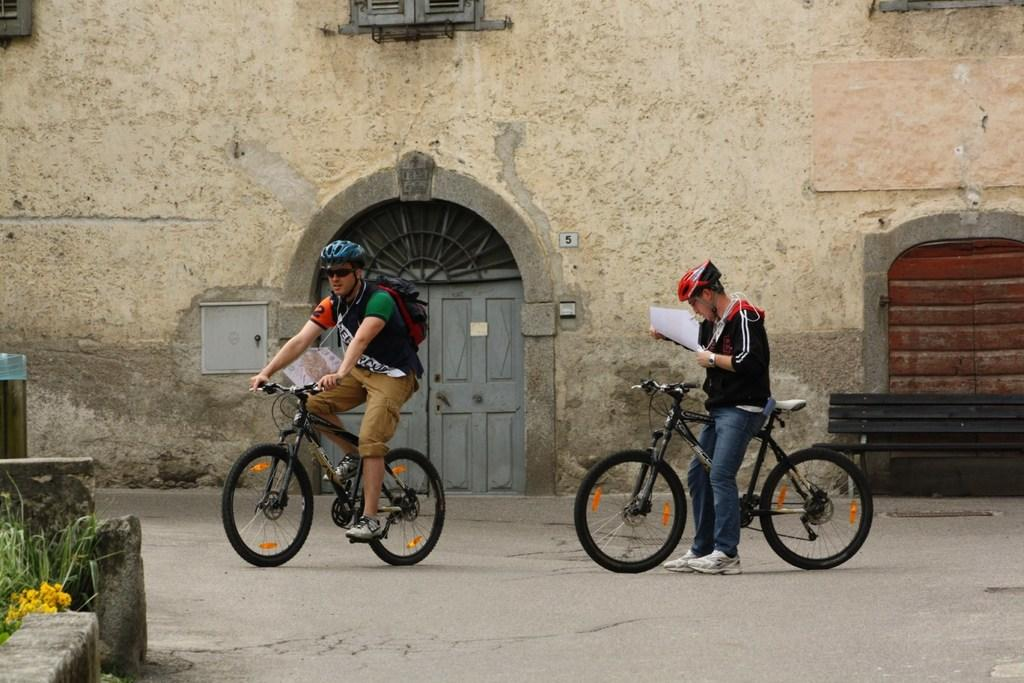How many people are in the image? There are two persons in the image. What are the persons doing in the image? The persons are on bicycles. What can be seen in the background of the image? There is a building, doors, windows, an electric shaft, and plants in the background of the image. What are the names of the dinosaurs in the image? There are no dinosaurs present in the image. How big is the yard in the image? There is no yard visible in the image. 